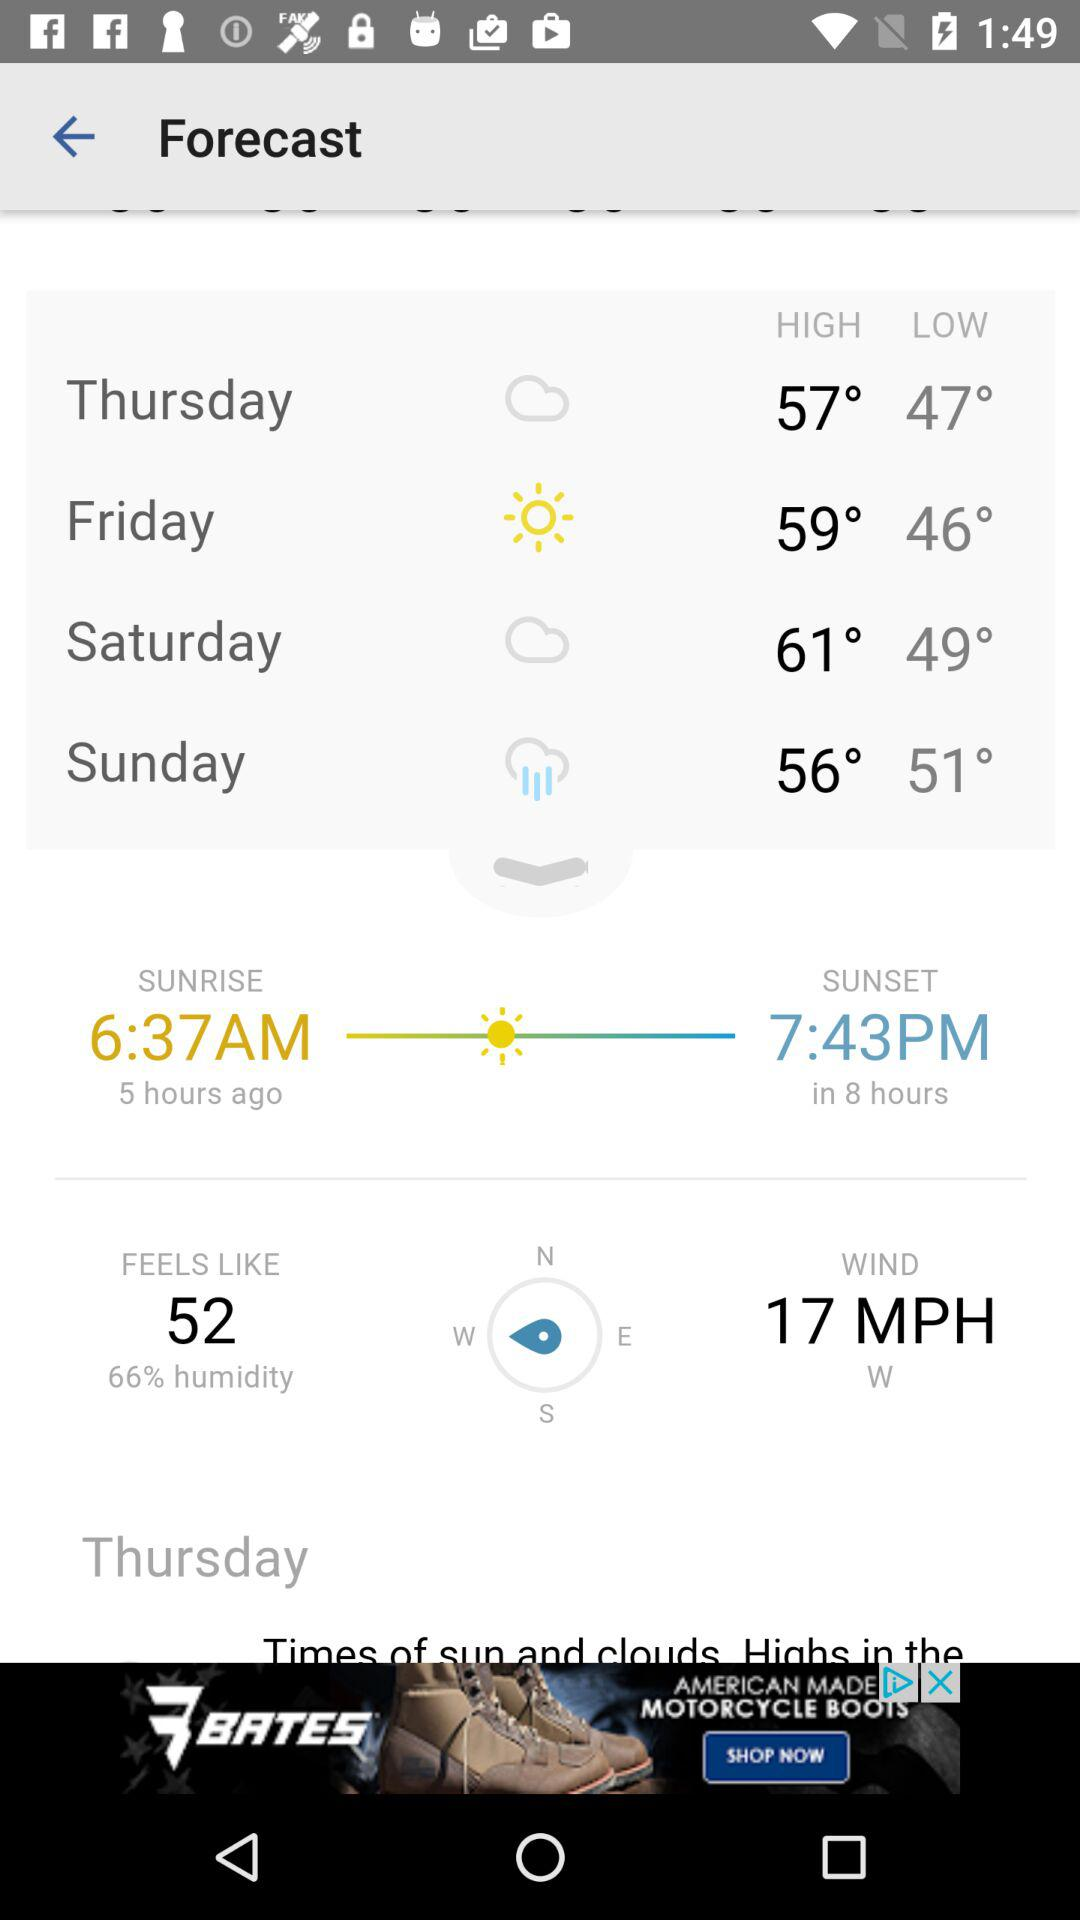How’s the weather on Thursday? The weather is cloudy. 